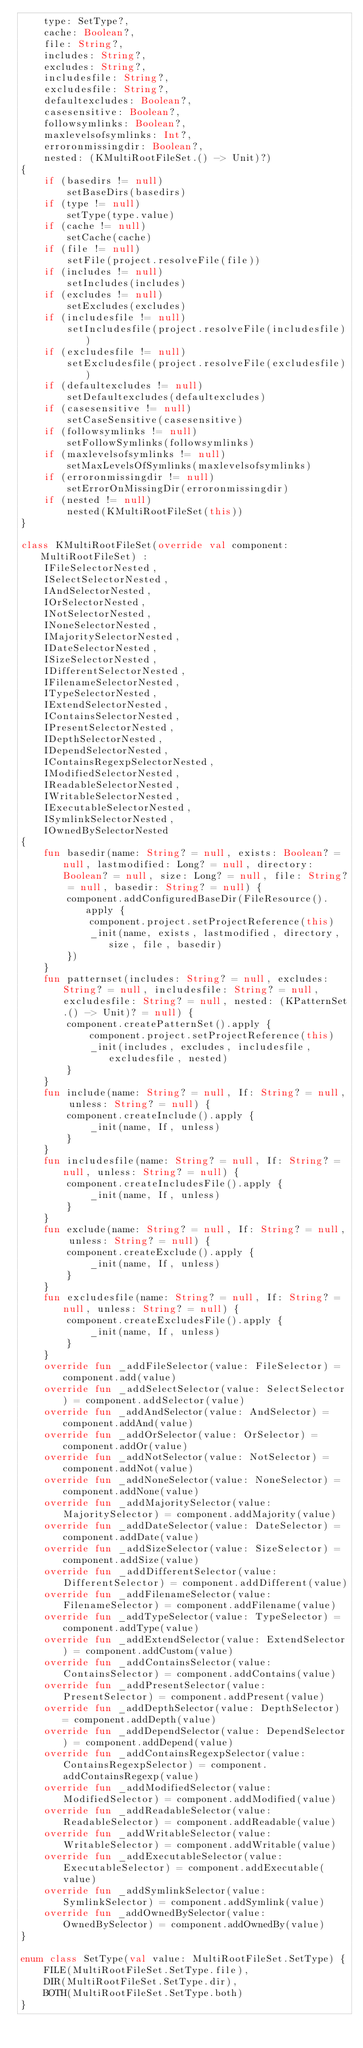<code> <loc_0><loc_0><loc_500><loc_500><_Kotlin_>	type: SetType?,
	cache: Boolean?,
	file: String?,
	includes: String?,
	excludes: String?,
	includesfile: String?,
	excludesfile: String?,
	defaultexcludes: Boolean?,
	casesensitive: Boolean?,
	followsymlinks: Boolean?,
	maxlevelsofsymlinks: Int?,
	erroronmissingdir: Boolean?,
	nested: (KMultiRootFileSet.() -> Unit)?)
{
	if (basedirs != null)
		setBaseDirs(basedirs)
	if (type != null)
		setType(type.value)
	if (cache != null)
		setCache(cache)
	if (file != null)
		setFile(project.resolveFile(file))
	if (includes != null)
		setIncludes(includes)
	if (excludes != null)
		setExcludes(excludes)
	if (includesfile != null)
		setIncludesfile(project.resolveFile(includesfile))
	if (excludesfile != null)
		setExcludesfile(project.resolveFile(excludesfile))
	if (defaultexcludes != null)
		setDefaultexcludes(defaultexcludes)
	if (casesensitive != null)
		setCaseSensitive(casesensitive)
	if (followsymlinks != null)
		setFollowSymlinks(followsymlinks)
	if (maxlevelsofsymlinks != null)
		setMaxLevelsOfSymlinks(maxlevelsofsymlinks)
	if (erroronmissingdir != null)
		setErrorOnMissingDir(erroronmissingdir)
	if (nested != null)
		nested(KMultiRootFileSet(this))
}

class KMultiRootFileSet(override val component: MultiRootFileSet) :
	IFileSelectorNested,
	ISelectSelectorNested,
	IAndSelectorNested,
	IOrSelectorNested,
	INotSelectorNested,
	INoneSelectorNested,
	IMajoritySelectorNested,
	IDateSelectorNested,
	ISizeSelectorNested,
	IDifferentSelectorNested,
	IFilenameSelectorNested,
	ITypeSelectorNested,
	IExtendSelectorNested,
	IContainsSelectorNested,
	IPresentSelectorNested,
	IDepthSelectorNested,
	IDependSelectorNested,
	IContainsRegexpSelectorNested,
	IModifiedSelectorNested,
	IReadableSelectorNested,
	IWritableSelectorNested,
	IExecutableSelectorNested,
	ISymlinkSelectorNested,
	IOwnedBySelectorNested
{
	fun basedir(name: String? = null, exists: Boolean? = null, lastmodified: Long? = null, directory: Boolean? = null, size: Long? = null, file: String? = null, basedir: String? = null) {
		component.addConfiguredBaseDir(FileResource().apply {
			component.project.setProjectReference(this)
			_init(name, exists, lastmodified, directory, size, file, basedir)
		})
	}
	fun patternset(includes: String? = null, excludes: String? = null, includesfile: String? = null, excludesfile: String? = null, nested: (KPatternSet.() -> Unit)? = null) {
		component.createPatternSet().apply {
			component.project.setProjectReference(this)
			_init(includes, excludes, includesfile, excludesfile, nested)
		}
	}
	fun include(name: String? = null, If: String? = null, unless: String? = null) {
		component.createInclude().apply {
			_init(name, If, unless)
		}
	}
	fun includesfile(name: String? = null, If: String? = null, unless: String? = null) {
		component.createIncludesFile().apply {
			_init(name, If, unless)
		}
	}
	fun exclude(name: String? = null, If: String? = null, unless: String? = null) {
		component.createExclude().apply {
			_init(name, If, unless)
		}
	}
	fun excludesfile(name: String? = null, If: String? = null, unless: String? = null) {
		component.createExcludesFile().apply {
			_init(name, If, unless)
		}
	}
	override fun _addFileSelector(value: FileSelector) = component.add(value)
	override fun _addSelectSelector(value: SelectSelector) = component.addSelector(value)
	override fun _addAndSelector(value: AndSelector) = component.addAnd(value)
	override fun _addOrSelector(value: OrSelector) = component.addOr(value)
	override fun _addNotSelector(value: NotSelector) = component.addNot(value)
	override fun _addNoneSelector(value: NoneSelector) = component.addNone(value)
	override fun _addMajoritySelector(value: MajoritySelector) = component.addMajority(value)
	override fun _addDateSelector(value: DateSelector) = component.addDate(value)
	override fun _addSizeSelector(value: SizeSelector) = component.addSize(value)
	override fun _addDifferentSelector(value: DifferentSelector) = component.addDifferent(value)
	override fun _addFilenameSelector(value: FilenameSelector) = component.addFilename(value)
	override fun _addTypeSelector(value: TypeSelector) = component.addType(value)
	override fun _addExtendSelector(value: ExtendSelector) = component.addCustom(value)
	override fun _addContainsSelector(value: ContainsSelector) = component.addContains(value)
	override fun _addPresentSelector(value: PresentSelector) = component.addPresent(value)
	override fun _addDepthSelector(value: DepthSelector) = component.addDepth(value)
	override fun _addDependSelector(value: DependSelector) = component.addDepend(value)
	override fun _addContainsRegexpSelector(value: ContainsRegexpSelector) = component.addContainsRegexp(value)
	override fun _addModifiedSelector(value: ModifiedSelector) = component.addModified(value)
	override fun _addReadableSelector(value: ReadableSelector) = component.addReadable(value)
	override fun _addWritableSelector(value: WritableSelector) = component.addWritable(value)
	override fun _addExecutableSelector(value: ExecutableSelector) = component.addExecutable(value)
	override fun _addSymlinkSelector(value: SymlinkSelector) = component.addSymlink(value)
	override fun _addOwnedBySelector(value: OwnedBySelector) = component.addOwnedBy(value)
}

enum class SetType(val value: MultiRootFileSet.SetType) {
	FILE(MultiRootFileSet.SetType.file),
	DIR(MultiRootFileSet.SetType.dir),
	BOTH(MultiRootFileSet.SetType.both)
}
</code> 